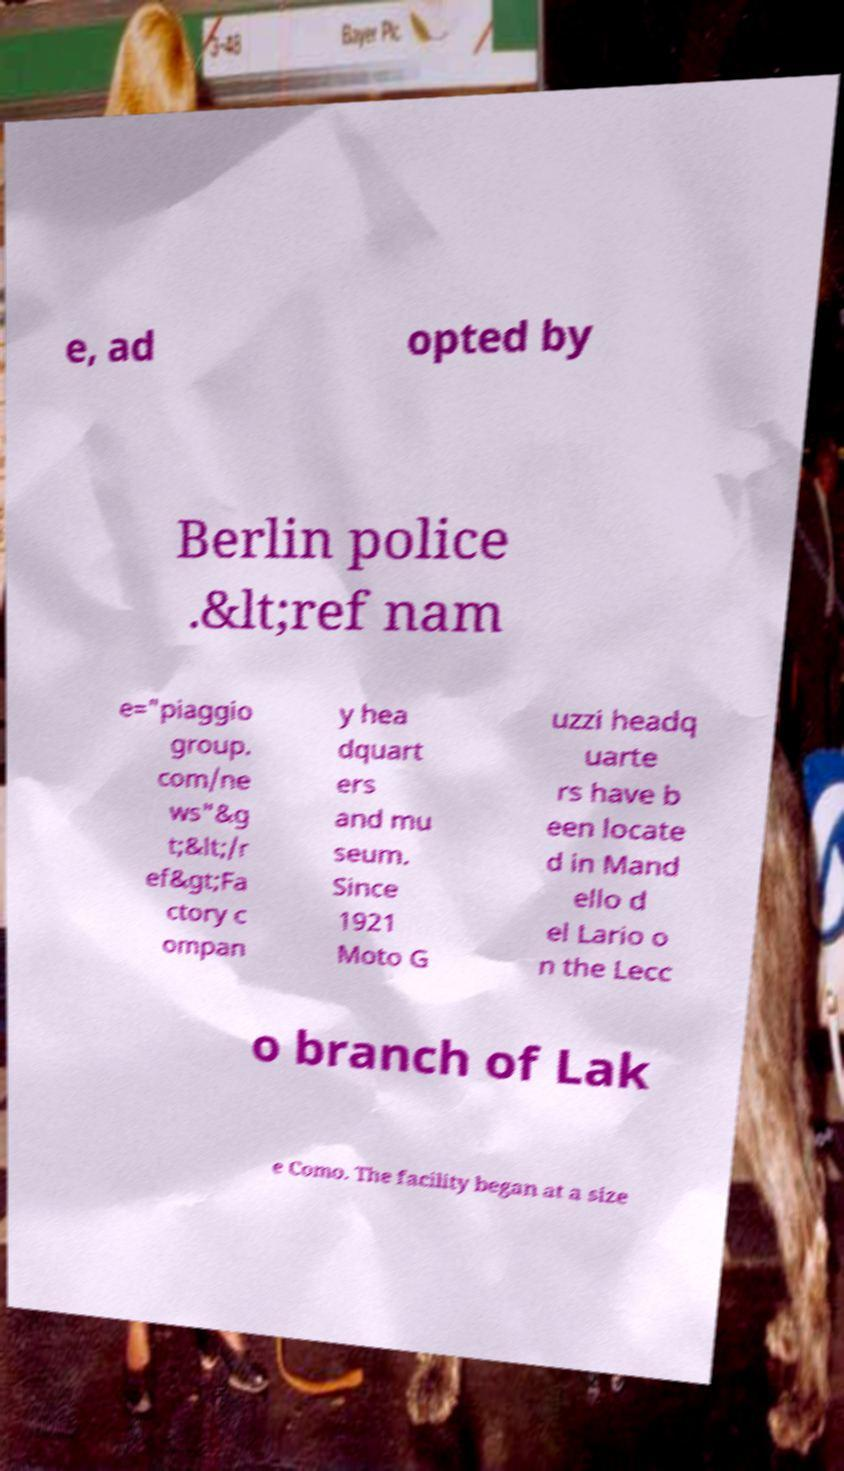For documentation purposes, I need the text within this image transcribed. Could you provide that? e, ad opted by Berlin police .&lt;ref nam e="piaggio group. com/ne ws"&g t;&lt;/r ef&gt;Fa ctory c ompan y hea dquart ers and mu seum. Since 1921 Moto G uzzi headq uarte rs have b een locate d in Mand ello d el Lario o n the Lecc o branch of Lak e Como. The facility began at a size 